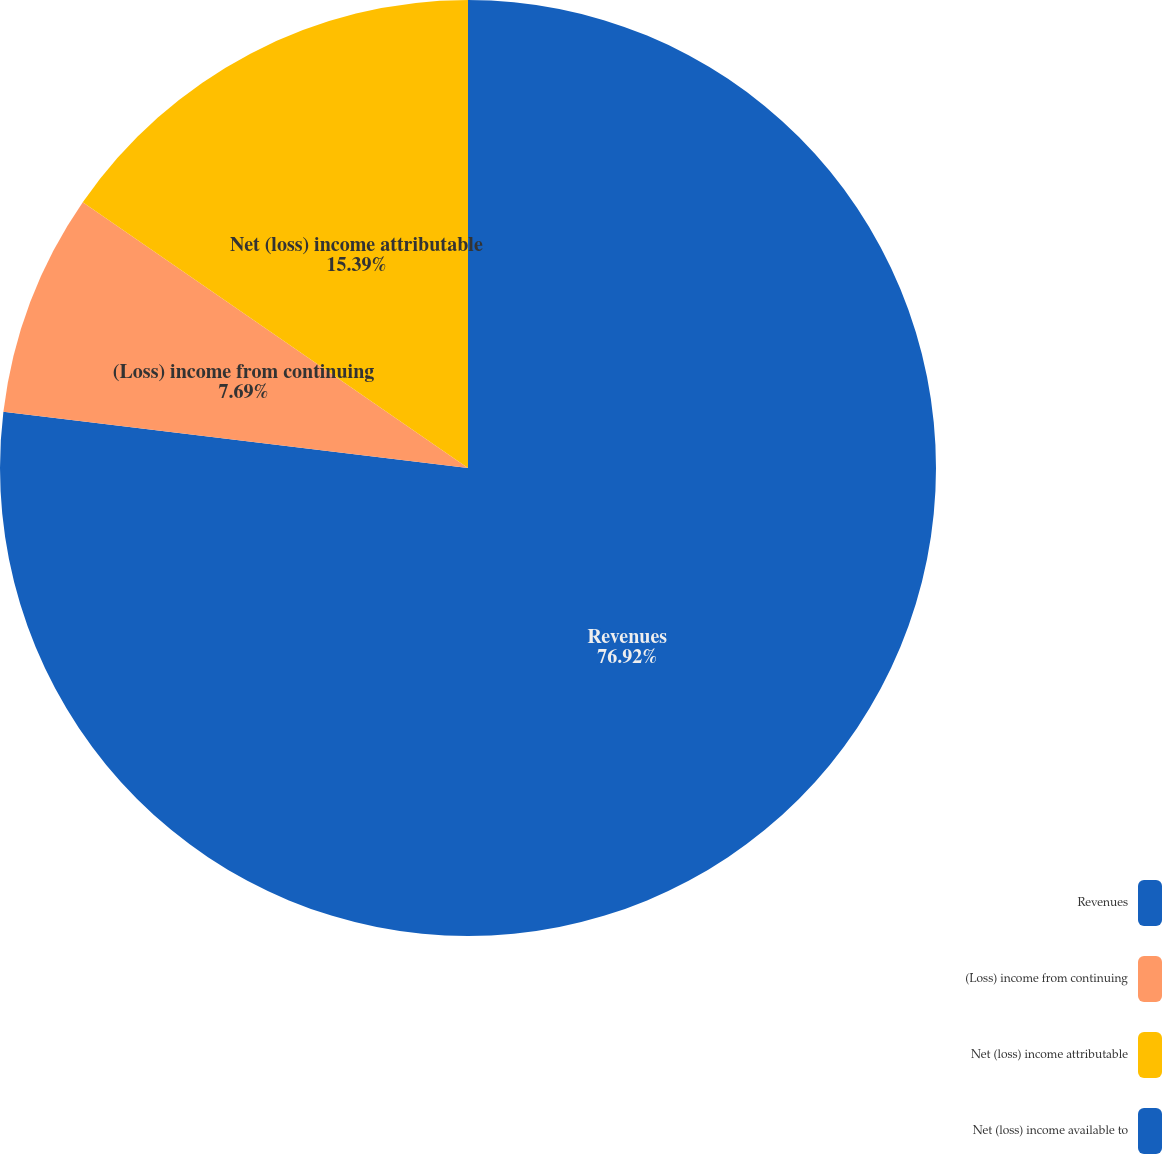<chart> <loc_0><loc_0><loc_500><loc_500><pie_chart><fcel>Revenues<fcel>(Loss) income from continuing<fcel>Net (loss) income attributable<fcel>Net (loss) income available to<nl><fcel>76.92%<fcel>7.69%<fcel>15.39%<fcel>0.0%<nl></chart> 